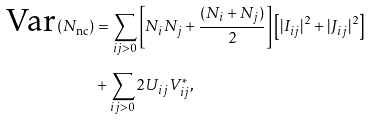Convert formula to latex. <formula><loc_0><loc_0><loc_500><loc_500>\text {Var} ( N _ { \text {nc} } ) & = \sum _ { i j > 0 } \left [ N _ { i } N _ { j } + \frac { ( N _ { i } + N _ { j } ) } { 2 } \right ] \left [ | I _ { i j } | ^ { 2 } + | J _ { i j } | ^ { 2 } \right ] \\ & + \sum _ { i j > 0 } 2 U _ { i j } V _ { i j } ^ { * } ,</formula> 